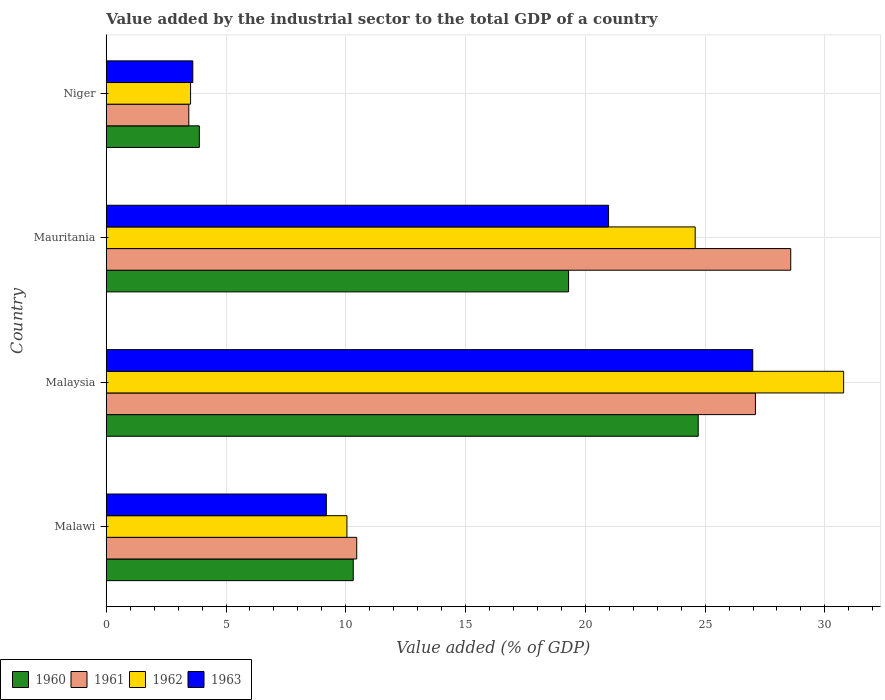How many groups of bars are there?
Offer a terse response. 4. How many bars are there on the 2nd tick from the top?
Your answer should be very brief. 4. How many bars are there on the 4th tick from the bottom?
Offer a terse response. 4. What is the label of the 4th group of bars from the top?
Make the answer very short. Malawi. In how many cases, is the number of bars for a given country not equal to the number of legend labels?
Give a very brief answer. 0. What is the value added by the industrial sector to the total GDP in 1962 in Malaysia?
Keep it short and to the point. 30.78. Across all countries, what is the maximum value added by the industrial sector to the total GDP in 1962?
Your response must be concise. 30.78. Across all countries, what is the minimum value added by the industrial sector to the total GDP in 1960?
Provide a succinct answer. 3.89. In which country was the value added by the industrial sector to the total GDP in 1960 maximum?
Offer a terse response. Malaysia. In which country was the value added by the industrial sector to the total GDP in 1963 minimum?
Ensure brevity in your answer.  Niger. What is the total value added by the industrial sector to the total GDP in 1963 in the graph?
Ensure brevity in your answer.  60.76. What is the difference between the value added by the industrial sector to the total GDP in 1962 in Malaysia and that in Niger?
Offer a terse response. 27.26. What is the difference between the value added by the industrial sector to the total GDP in 1962 in Mauritania and the value added by the industrial sector to the total GDP in 1963 in Niger?
Keep it short and to the point. 20.97. What is the average value added by the industrial sector to the total GDP in 1960 per country?
Your answer should be very brief. 14.55. What is the difference between the value added by the industrial sector to the total GDP in 1960 and value added by the industrial sector to the total GDP in 1961 in Niger?
Your answer should be compact. 0.44. In how many countries, is the value added by the industrial sector to the total GDP in 1962 greater than 26 %?
Keep it short and to the point. 1. What is the ratio of the value added by the industrial sector to the total GDP in 1961 in Malawi to that in Niger?
Provide a short and direct response. 3.03. What is the difference between the highest and the second highest value added by the industrial sector to the total GDP in 1962?
Offer a very short reply. 6.2. What is the difference between the highest and the lowest value added by the industrial sector to the total GDP in 1962?
Provide a succinct answer. 27.26. Is the sum of the value added by the industrial sector to the total GDP in 1963 in Malawi and Niger greater than the maximum value added by the industrial sector to the total GDP in 1960 across all countries?
Your answer should be compact. No. What does the 4th bar from the bottom in Niger represents?
Ensure brevity in your answer.  1963. Is it the case that in every country, the sum of the value added by the industrial sector to the total GDP in 1962 and value added by the industrial sector to the total GDP in 1961 is greater than the value added by the industrial sector to the total GDP in 1963?
Make the answer very short. Yes. How many bars are there?
Offer a very short reply. 16. Where does the legend appear in the graph?
Your answer should be compact. Bottom left. What is the title of the graph?
Offer a very short reply. Value added by the industrial sector to the total GDP of a country. Does "2002" appear as one of the legend labels in the graph?
Your answer should be compact. No. What is the label or title of the X-axis?
Offer a terse response. Value added (% of GDP). What is the Value added (% of GDP) in 1960 in Malawi?
Offer a very short reply. 10.31. What is the Value added (% of GDP) of 1961 in Malawi?
Offer a very short reply. 10.46. What is the Value added (% of GDP) of 1962 in Malawi?
Make the answer very short. 10.05. What is the Value added (% of GDP) of 1963 in Malawi?
Your answer should be compact. 9.19. What is the Value added (% of GDP) of 1960 in Malaysia?
Your response must be concise. 24.71. What is the Value added (% of GDP) of 1961 in Malaysia?
Your answer should be very brief. 27.1. What is the Value added (% of GDP) in 1962 in Malaysia?
Keep it short and to the point. 30.78. What is the Value added (% of GDP) of 1963 in Malaysia?
Your answer should be compact. 26.99. What is the Value added (% of GDP) in 1960 in Mauritania?
Offer a very short reply. 19.3. What is the Value added (% of GDP) in 1961 in Mauritania?
Your answer should be very brief. 28.57. What is the Value added (% of GDP) of 1962 in Mauritania?
Ensure brevity in your answer.  24.59. What is the Value added (% of GDP) in 1963 in Mauritania?
Offer a terse response. 20.97. What is the Value added (% of GDP) in 1960 in Niger?
Give a very brief answer. 3.89. What is the Value added (% of GDP) in 1961 in Niger?
Keep it short and to the point. 3.45. What is the Value added (% of GDP) in 1962 in Niger?
Offer a very short reply. 3.52. What is the Value added (% of GDP) of 1963 in Niger?
Your answer should be very brief. 3.61. Across all countries, what is the maximum Value added (% of GDP) of 1960?
Offer a terse response. 24.71. Across all countries, what is the maximum Value added (% of GDP) of 1961?
Your answer should be very brief. 28.57. Across all countries, what is the maximum Value added (% of GDP) in 1962?
Ensure brevity in your answer.  30.78. Across all countries, what is the maximum Value added (% of GDP) of 1963?
Make the answer very short. 26.99. Across all countries, what is the minimum Value added (% of GDP) in 1960?
Your response must be concise. 3.89. Across all countries, what is the minimum Value added (% of GDP) in 1961?
Keep it short and to the point. 3.45. Across all countries, what is the minimum Value added (% of GDP) of 1962?
Your answer should be very brief. 3.52. Across all countries, what is the minimum Value added (% of GDP) of 1963?
Keep it short and to the point. 3.61. What is the total Value added (% of GDP) of 1960 in the graph?
Keep it short and to the point. 58.21. What is the total Value added (% of GDP) in 1961 in the graph?
Provide a short and direct response. 69.58. What is the total Value added (% of GDP) of 1962 in the graph?
Provide a short and direct response. 68.93. What is the total Value added (% of GDP) in 1963 in the graph?
Your answer should be compact. 60.76. What is the difference between the Value added (% of GDP) in 1960 in Malawi and that in Malaysia?
Keep it short and to the point. -14.4. What is the difference between the Value added (% of GDP) in 1961 in Malawi and that in Malaysia?
Keep it short and to the point. -16.64. What is the difference between the Value added (% of GDP) in 1962 in Malawi and that in Malaysia?
Your response must be concise. -20.73. What is the difference between the Value added (% of GDP) of 1963 in Malawi and that in Malaysia?
Provide a succinct answer. -17.8. What is the difference between the Value added (% of GDP) of 1960 in Malawi and that in Mauritania?
Offer a terse response. -8.99. What is the difference between the Value added (% of GDP) of 1961 in Malawi and that in Mauritania?
Give a very brief answer. -18.12. What is the difference between the Value added (% of GDP) in 1962 in Malawi and that in Mauritania?
Provide a short and direct response. -14.54. What is the difference between the Value added (% of GDP) in 1963 in Malawi and that in Mauritania?
Your answer should be compact. -11.78. What is the difference between the Value added (% of GDP) of 1960 in Malawi and that in Niger?
Keep it short and to the point. 6.43. What is the difference between the Value added (% of GDP) of 1961 in Malawi and that in Niger?
Your response must be concise. 7.01. What is the difference between the Value added (% of GDP) in 1962 in Malawi and that in Niger?
Offer a terse response. 6.53. What is the difference between the Value added (% of GDP) in 1963 in Malawi and that in Niger?
Give a very brief answer. 5.57. What is the difference between the Value added (% of GDP) in 1960 in Malaysia and that in Mauritania?
Give a very brief answer. 5.41. What is the difference between the Value added (% of GDP) in 1961 in Malaysia and that in Mauritania?
Give a very brief answer. -1.47. What is the difference between the Value added (% of GDP) in 1962 in Malaysia and that in Mauritania?
Offer a very short reply. 6.2. What is the difference between the Value added (% of GDP) of 1963 in Malaysia and that in Mauritania?
Your answer should be very brief. 6.02. What is the difference between the Value added (% of GDP) in 1960 in Malaysia and that in Niger?
Give a very brief answer. 20.83. What is the difference between the Value added (% of GDP) in 1961 in Malaysia and that in Niger?
Provide a succinct answer. 23.65. What is the difference between the Value added (% of GDP) in 1962 in Malaysia and that in Niger?
Keep it short and to the point. 27.26. What is the difference between the Value added (% of GDP) of 1963 in Malaysia and that in Niger?
Give a very brief answer. 23.38. What is the difference between the Value added (% of GDP) of 1960 in Mauritania and that in Niger?
Ensure brevity in your answer.  15.41. What is the difference between the Value added (% of GDP) in 1961 in Mauritania and that in Niger?
Offer a very short reply. 25.13. What is the difference between the Value added (% of GDP) of 1962 in Mauritania and that in Niger?
Keep it short and to the point. 21.07. What is the difference between the Value added (% of GDP) of 1963 in Mauritania and that in Niger?
Provide a succinct answer. 17.36. What is the difference between the Value added (% of GDP) of 1960 in Malawi and the Value added (% of GDP) of 1961 in Malaysia?
Offer a terse response. -16.79. What is the difference between the Value added (% of GDP) of 1960 in Malawi and the Value added (% of GDP) of 1962 in Malaysia?
Your answer should be compact. -20.47. What is the difference between the Value added (% of GDP) of 1960 in Malawi and the Value added (% of GDP) of 1963 in Malaysia?
Your answer should be very brief. -16.68. What is the difference between the Value added (% of GDP) in 1961 in Malawi and the Value added (% of GDP) in 1962 in Malaysia?
Provide a succinct answer. -20.33. What is the difference between the Value added (% of GDP) in 1961 in Malawi and the Value added (% of GDP) in 1963 in Malaysia?
Your answer should be very brief. -16.53. What is the difference between the Value added (% of GDP) of 1962 in Malawi and the Value added (% of GDP) of 1963 in Malaysia?
Make the answer very short. -16.94. What is the difference between the Value added (% of GDP) in 1960 in Malawi and the Value added (% of GDP) in 1961 in Mauritania?
Make the answer very short. -18.26. What is the difference between the Value added (% of GDP) in 1960 in Malawi and the Value added (% of GDP) in 1962 in Mauritania?
Your response must be concise. -14.27. What is the difference between the Value added (% of GDP) in 1960 in Malawi and the Value added (% of GDP) in 1963 in Mauritania?
Ensure brevity in your answer.  -10.66. What is the difference between the Value added (% of GDP) of 1961 in Malawi and the Value added (% of GDP) of 1962 in Mauritania?
Your response must be concise. -14.13. What is the difference between the Value added (% of GDP) in 1961 in Malawi and the Value added (% of GDP) in 1963 in Mauritania?
Offer a terse response. -10.51. What is the difference between the Value added (% of GDP) in 1962 in Malawi and the Value added (% of GDP) in 1963 in Mauritania?
Give a very brief answer. -10.92. What is the difference between the Value added (% of GDP) of 1960 in Malawi and the Value added (% of GDP) of 1961 in Niger?
Provide a short and direct response. 6.86. What is the difference between the Value added (% of GDP) in 1960 in Malawi and the Value added (% of GDP) in 1962 in Niger?
Provide a succinct answer. 6.79. What is the difference between the Value added (% of GDP) of 1960 in Malawi and the Value added (% of GDP) of 1963 in Niger?
Your answer should be compact. 6.7. What is the difference between the Value added (% of GDP) in 1961 in Malawi and the Value added (% of GDP) in 1962 in Niger?
Ensure brevity in your answer.  6.94. What is the difference between the Value added (% of GDP) of 1961 in Malawi and the Value added (% of GDP) of 1963 in Niger?
Your answer should be compact. 6.84. What is the difference between the Value added (% of GDP) in 1962 in Malawi and the Value added (% of GDP) in 1963 in Niger?
Offer a terse response. 6.43. What is the difference between the Value added (% of GDP) of 1960 in Malaysia and the Value added (% of GDP) of 1961 in Mauritania?
Offer a terse response. -3.86. What is the difference between the Value added (% of GDP) in 1960 in Malaysia and the Value added (% of GDP) in 1962 in Mauritania?
Provide a succinct answer. 0.13. What is the difference between the Value added (% of GDP) in 1960 in Malaysia and the Value added (% of GDP) in 1963 in Mauritania?
Offer a very short reply. 3.74. What is the difference between the Value added (% of GDP) of 1961 in Malaysia and the Value added (% of GDP) of 1962 in Mauritania?
Give a very brief answer. 2.51. What is the difference between the Value added (% of GDP) of 1961 in Malaysia and the Value added (% of GDP) of 1963 in Mauritania?
Your answer should be compact. 6.13. What is the difference between the Value added (% of GDP) of 1962 in Malaysia and the Value added (% of GDP) of 1963 in Mauritania?
Your response must be concise. 9.81. What is the difference between the Value added (% of GDP) of 1960 in Malaysia and the Value added (% of GDP) of 1961 in Niger?
Give a very brief answer. 21.27. What is the difference between the Value added (% of GDP) in 1960 in Malaysia and the Value added (% of GDP) in 1962 in Niger?
Your response must be concise. 21.19. What is the difference between the Value added (% of GDP) in 1960 in Malaysia and the Value added (% of GDP) in 1963 in Niger?
Give a very brief answer. 21.1. What is the difference between the Value added (% of GDP) of 1961 in Malaysia and the Value added (% of GDP) of 1962 in Niger?
Offer a very short reply. 23.58. What is the difference between the Value added (% of GDP) of 1961 in Malaysia and the Value added (% of GDP) of 1963 in Niger?
Offer a very short reply. 23.49. What is the difference between the Value added (% of GDP) in 1962 in Malaysia and the Value added (% of GDP) in 1963 in Niger?
Provide a succinct answer. 27.17. What is the difference between the Value added (% of GDP) of 1960 in Mauritania and the Value added (% of GDP) of 1961 in Niger?
Your response must be concise. 15.85. What is the difference between the Value added (% of GDP) of 1960 in Mauritania and the Value added (% of GDP) of 1962 in Niger?
Offer a terse response. 15.78. What is the difference between the Value added (% of GDP) in 1960 in Mauritania and the Value added (% of GDP) in 1963 in Niger?
Offer a very short reply. 15.69. What is the difference between the Value added (% of GDP) in 1961 in Mauritania and the Value added (% of GDP) in 1962 in Niger?
Provide a short and direct response. 25.05. What is the difference between the Value added (% of GDP) of 1961 in Mauritania and the Value added (% of GDP) of 1963 in Niger?
Your answer should be compact. 24.96. What is the difference between the Value added (% of GDP) of 1962 in Mauritania and the Value added (% of GDP) of 1963 in Niger?
Your answer should be compact. 20.97. What is the average Value added (% of GDP) of 1960 per country?
Your answer should be compact. 14.55. What is the average Value added (% of GDP) in 1961 per country?
Provide a succinct answer. 17.39. What is the average Value added (% of GDP) of 1962 per country?
Your answer should be compact. 17.23. What is the average Value added (% of GDP) of 1963 per country?
Ensure brevity in your answer.  15.19. What is the difference between the Value added (% of GDP) in 1960 and Value added (% of GDP) in 1961 in Malawi?
Offer a very short reply. -0.15. What is the difference between the Value added (% of GDP) in 1960 and Value added (% of GDP) in 1962 in Malawi?
Your answer should be compact. 0.26. What is the difference between the Value added (% of GDP) of 1960 and Value added (% of GDP) of 1963 in Malawi?
Give a very brief answer. 1.12. What is the difference between the Value added (% of GDP) in 1961 and Value added (% of GDP) in 1962 in Malawi?
Keep it short and to the point. 0.41. What is the difference between the Value added (% of GDP) in 1961 and Value added (% of GDP) in 1963 in Malawi?
Ensure brevity in your answer.  1.27. What is the difference between the Value added (% of GDP) of 1962 and Value added (% of GDP) of 1963 in Malawi?
Your answer should be compact. 0.86. What is the difference between the Value added (% of GDP) in 1960 and Value added (% of GDP) in 1961 in Malaysia?
Your answer should be very brief. -2.39. What is the difference between the Value added (% of GDP) in 1960 and Value added (% of GDP) in 1962 in Malaysia?
Your response must be concise. -6.07. What is the difference between the Value added (% of GDP) of 1960 and Value added (% of GDP) of 1963 in Malaysia?
Your answer should be compact. -2.28. What is the difference between the Value added (% of GDP) of 1961 and Value added (% of GDP) of 1962 in Malaysia?
Make the answer very short. -3.68. What is the difference between the Value added (% of GDP) of 1961 and Value added (% of GDP) of 1963 in Malaysia?
Offer a terse response. 0.11. What is the difference between the Value added (% of GDP) of 1962 and Value added (% of GDP) of 1963 in Malaysia?
Keep it short and to the point. 3.79. What is the difference between the Value added (% of GDP) of 1960 and Value added (% of GDP) of 1961 in Mauritania?
Offer a terse response. -9.27. What is the difference between the Value added (% of GDP) of 1960 and Value added (% of GDP) of 1962 in Mauritania?
Offer a very short reply. -5.29. What is the difference between the Value added (% of GDP) of 1960 and Value added (% of GDP) of 1963 in Mauritania?
Your answer should be very brief. -1.67. What is the difference between the Value added (% of GDP) in 1961 and Value added (% of GDP) in 1962 in Mauritania?
Provide a succinct answer. 3.99. What is the difference between the Value added (% of GDP) in 1961 and Value added (% of GDP) in 1963 in Mauritania?
Your answer should be compact. 7.6. What is the difference between the Value added (% of GDP) in 1962 and Value added (% of GDP) in 1963 in Mauritania?
Make the answer very short. 3.62. What is the difference between the Value added (% of GDP) in 1960 and Value added (% of GDP) in 1961 in Niger?
Make the answer very short. 0.44. What is the difference between the Value added (% of GDP) of 1960 and Value added (% of GDP) of 1962 in Niger?
Your response must be concise. 0.37. What is the difference between the Value added (% of GDP) in 1960 and Value added (% of GDP) in 1963 in Niger?
Provide a short and direct response. 0.27. What is the difference between the Value added (% of GDP) of 1961 and Value added (% of GDP) of 1962 in Niger?
Give a very brief answer. -0.07. What is the difference between the Value added (% of GDP) of 1961 and Value added (% of GDP) of 1963 in Niger?
Make the answer very short. -0.17. What is the difference between the Value added (% of GDP) of 1962 and Value added (% of GDP) of 1963 in Niger?
Your response must be concise. -0.09. What is the ratio of the Value added (% of GDP) of 1960 in Malawi to that in Malaysia?
Provide a short and direct response. 0.42. What is the ratio of the Value added (% of GDP) in 1961 in Malawi to that in Malaysia?
Give a very brief answer. 0.39. What is the ratio of the Value added (% of GDP) of 1962 in Malawi to that in Malaysia?
Provide a short and direct response. 0.33. What is the ratio of the Value added (% of GDP) of 1963 in Malawi to that in Malaysia?
Your answer should be compact. 0.34. What is the ratio of the Value added (% of GDP) of 1960 in Malawi to that in Mauritania?
Make the answer very short. 0.53. What is the ratio of the Value added (% of GDP) of 1961 in Malawi to that in Mauritania?
Provide a succinct answer. 0.37. What is the ratio of the Value added (% of GDP) in 1962 in Malawi to that in Mauritania?
Give a very brief answer. 0.41. What is the ratio of the Value added (% of GDP) in 1963 in Malawi to that in Mauritania?
Provide a short and direct response. 0.44. What is the ratio of the Value added (% of GDP) of 1960 in Malawi to that in Niger?
Your response must be concise. 2.65. What is the ratio of the Value added (% of GDP) in 1961 in Malawi to that in Niger?
Offer a terse response. 3.03. What is the ratio of the Value added (% of GDP) in 1962 in Malawi to that in Niger?
Give a very brief answer. 2.85. What is the ratio of the Value added (% of GDP) of 1963 in Malawi to that in Niger?
Offer a terse response. 2.54. What is the ratio of the Value added (% of GDP) of 1960 in Malaysia to that in Mauritania?
Your response must be concise. 1.28. What is the ratio of the Value added (% of GDP) of 1961 in Malaysia to that in Mauritania?
Your response must be concise. 0.95. What is the ratio of the Value added (% of GDP) of 1962 in Malaysia to that in Mauritania?
Keep it short and to the point. 1.25. What is the ratio of the Value added (% of GDP) of 1963 in Malaysia to that in Mauritania?
Offer a very short reply. 1.29. What is the ratio of the Value added (% of GDP) of 1960 in Malaysia to that in Niger?
Offer a very short reply. 6.36. What is the ratio of the Value added (% of GDP) of 1961 in Malaysia to that in Niger?
Make the answer very short. 7.86. What is the ratio of the Value added (% of GDP) of 1962 in Malaysia to that in Niger?
Your answer should be compact. 8.75. What is the ratio of the Value added (% of GDP) of 1963 in Malaysia to that in Niger?
Ensure brevity in your answer.  7.47. What is the ratio of the Value added (% of GDP) of 1960 in Mauritania to that in Niger?
Keep it short and to the point. 4.97. What is the ratio of the Value added (% of GDP) of 1961 in Mauritania to that in Niger?
Offer a very short reply. 8.29. What is the ratio of the Value added (% of GDP) in 1962 in Mauritania to that in Niger?
Give a very brief answer. 6.99. What is the ratio of the Value added (% of GDP) of 1963 in Mauritania to that in Niger?
Provide a succinct answer. 5.8. What is the difference between the highest and the second highest Value added (% of GDP) in 1960?
Make the answer very short. 5.41. What is the difference between the highest and the second highest Value added (% of GDP) in 1961?
Ensure brevity in your answer.  1.47. What is the difference between the highest and the second highest Value added (% of GDP) of 1962?
Provide a short and direct response. 6.2. What is the difference between the highest and the second highest Value added (% of GDP) of 1963?
Your answer should be compact. 6.02. What is the difference between the highest and the lowest Value added (% of GDP) of 1960?
Ensure brevity in your answer.  20.83. What is the difference between the highest and the lowest Value added (% of GDP) of 1961?
Offer a very short reply. 25.13. What is the difference between the highest and the lowest Value added (% of GDP) in 1962?
Offer a terse response. 27.26. What is the difference between the highest and the lowest Value added (% of GDP) of 1963?
Your answer should be compact. 23.38. 